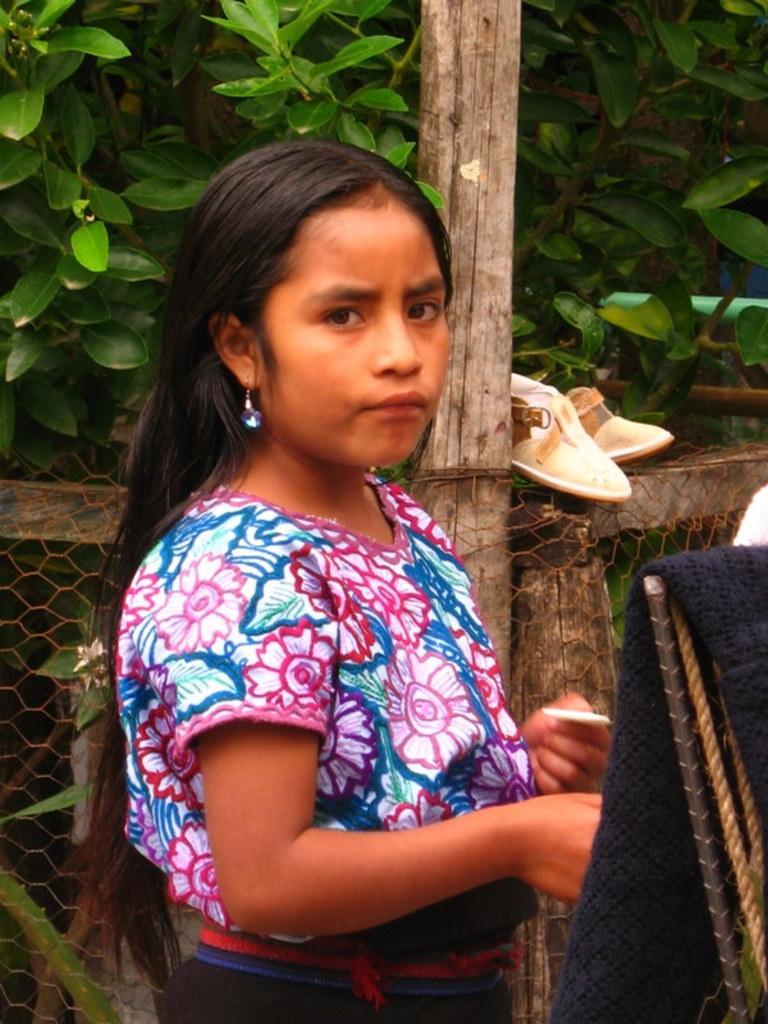How would you summarize this image in a sentence or two? Here in this picture we can see a woman present over there and behind her we can see a fencing present and we can see plants present all over there. 